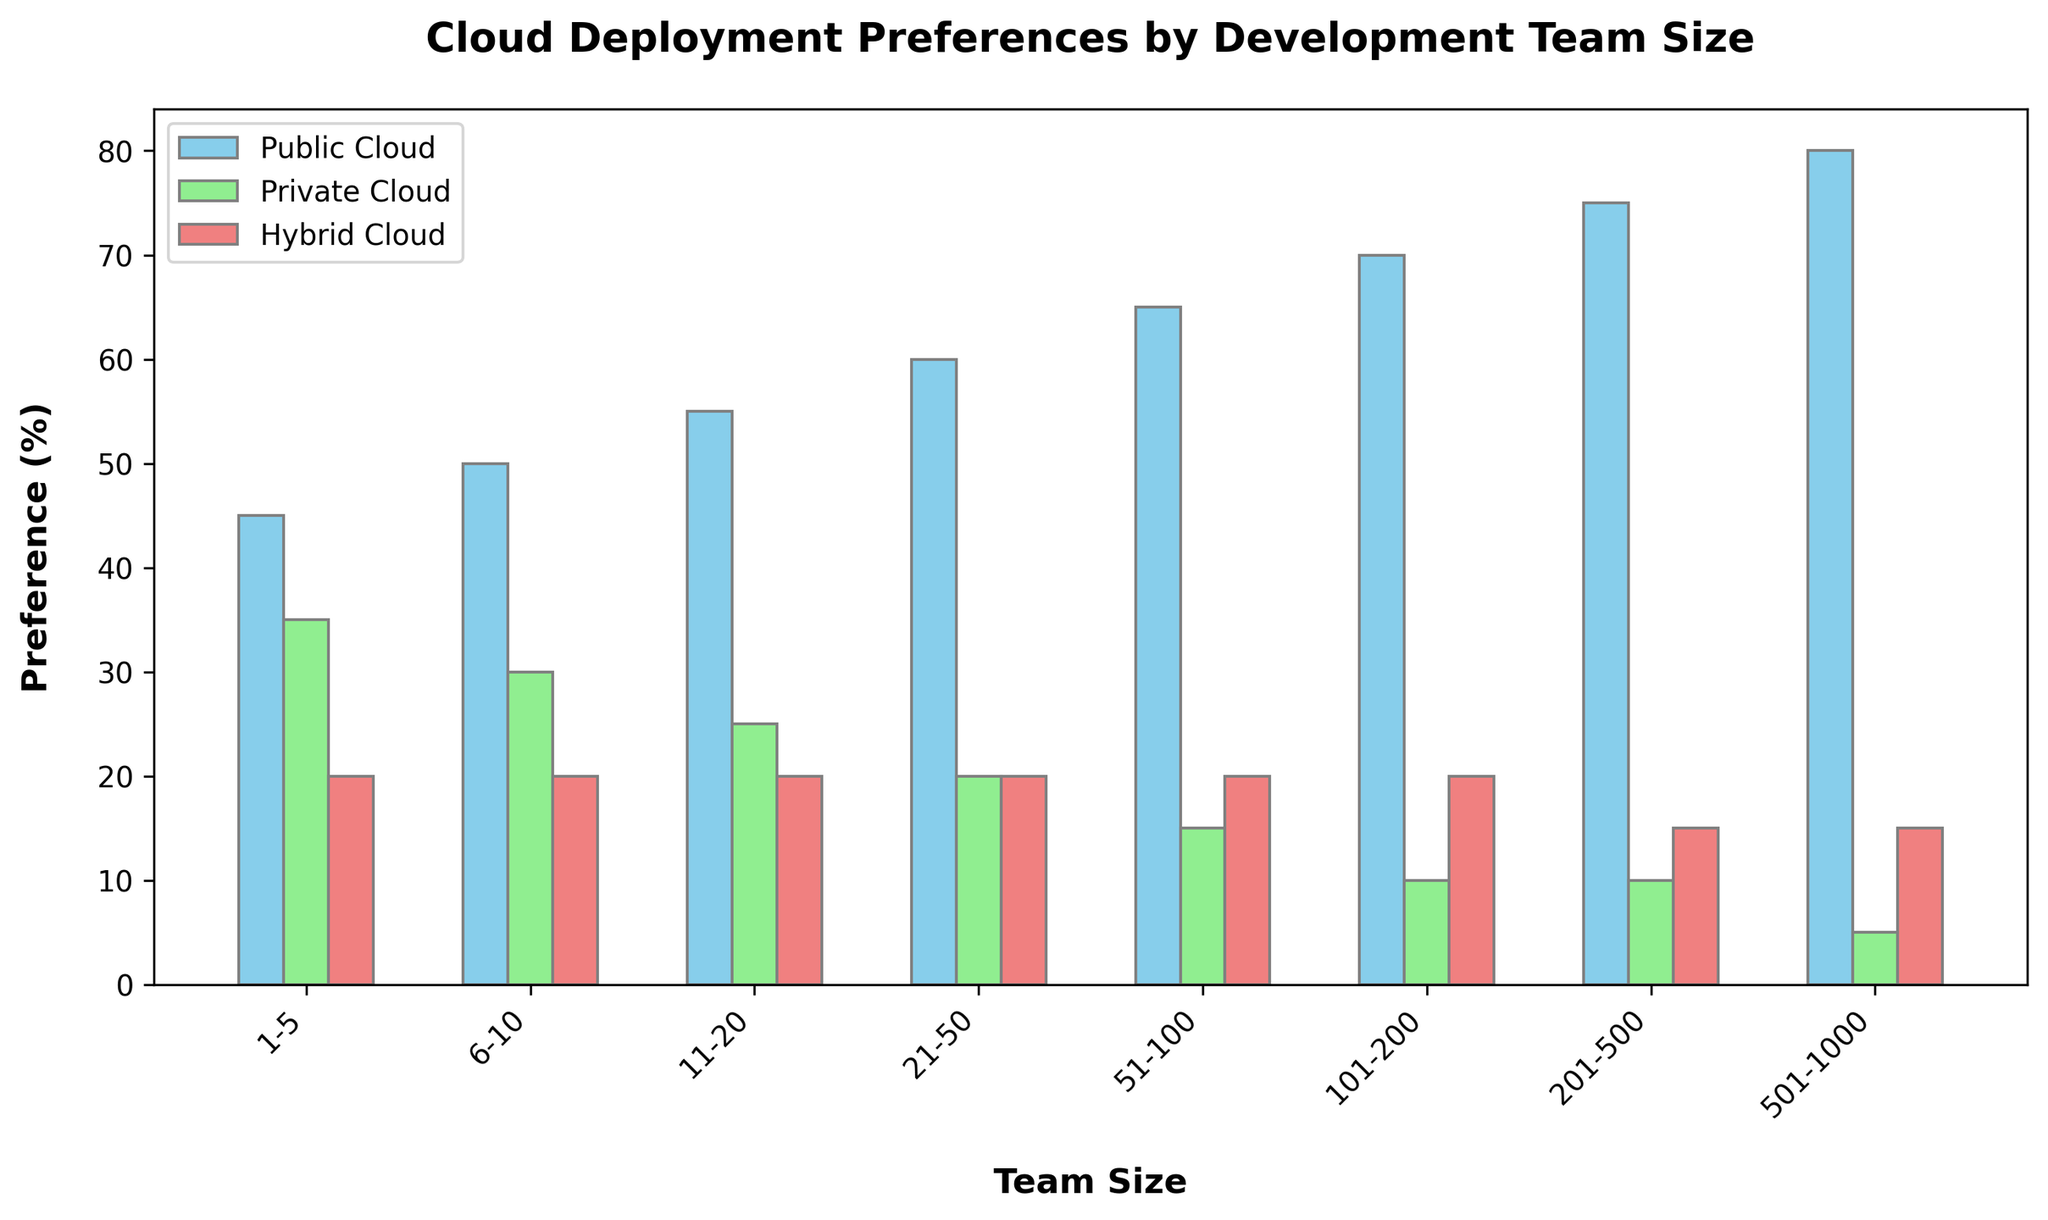what's the most preferred cloud deployment type for teams with 1-5 members? The figure shows values for Public Cloud, Private Cloud, and Hybrid Cloud for different team sizes. For teams with 1-5 members, we look at the height of the bars or the numerical values given. The Public Cloud has the highest bar at 45%.
Answer: Public Cloud which team size has the highest preference for Hybrid Cloud? To find this, look at the bars representing Hybrid Cloud deployment across different team sizes. All team sizes have a preference of 20% for Hybrid Cloud except for the larger team sizes (201-500 and 501-1000) which have a preference of 15%.
Answer: Teams with 1-200 members compare the preferences between Public Cloud and Private Cloud for teams with 51-100 members. Look at the height and exact percentages of bars for the Public Cloud and Private Cloud for the team size of 51-100. Public Cloud is at 65%, and Private Cloud is at 15%.
Answer: Public Cloud is more preferred by 50% what's the total percentage of teams with 21-50 members that prefer Private or Hybrid Cloud? For teams with 21-50 members, Private Cloud is at 20% and Hybrid Cloud is also at 20%. Adding them together gives 20% + 20% = 40%.
Answer: 40% which team size showed the lowest preference for Private Cloud? Check the bars representing the Private Cloud for the smallest values. The 501-1000 team size has the lowest bar at 5%.
Answer: 501-1000 members how does the preference for Public Cloud change as team size increases from 1-5 to 6-10? Look at the bar height for Public Cloud for team sizes 1-5 and 6-10. For 1-5, it is 45%. For 6-10, it is 50%, showing an increase of 5%.
Answer: It increases by 5% what's the average preference for Public Cloud across all team sizes? Sum up the Public Cloud preferences for all team sizes: (45 + 50 + 55 + 60 + 65 + 70 + 75 + 80) = 500. There are 8 data points, so the average is 500/8 = 62.5%.
Answer: 62.5% what percentage more do teams with 201-500 members prefer Public Cloud over Private Cloud? For 201-500 members, Public Cloud preference is 75%, and Private Cloud is 10%. Calculate the difference: 75% - 10% = 65%.
Answer: 65% which cloud type converges to a similar preference level across all team sizes, and what is that level? Look at the bars and identify a cloud type where the values are close across team sizes. Hybrid Cloud is at 20% for most team sizes, with small deviations for larger teams (201-500, 501-1000).
Answer: Hybrid Cloud, around 20% which cloud deployment type inversely correlates with team size? Check if any bar has decreasing height as the team size increases. The Private Cloud bar length decreases as team size increases.
Answer: Private Cloud 